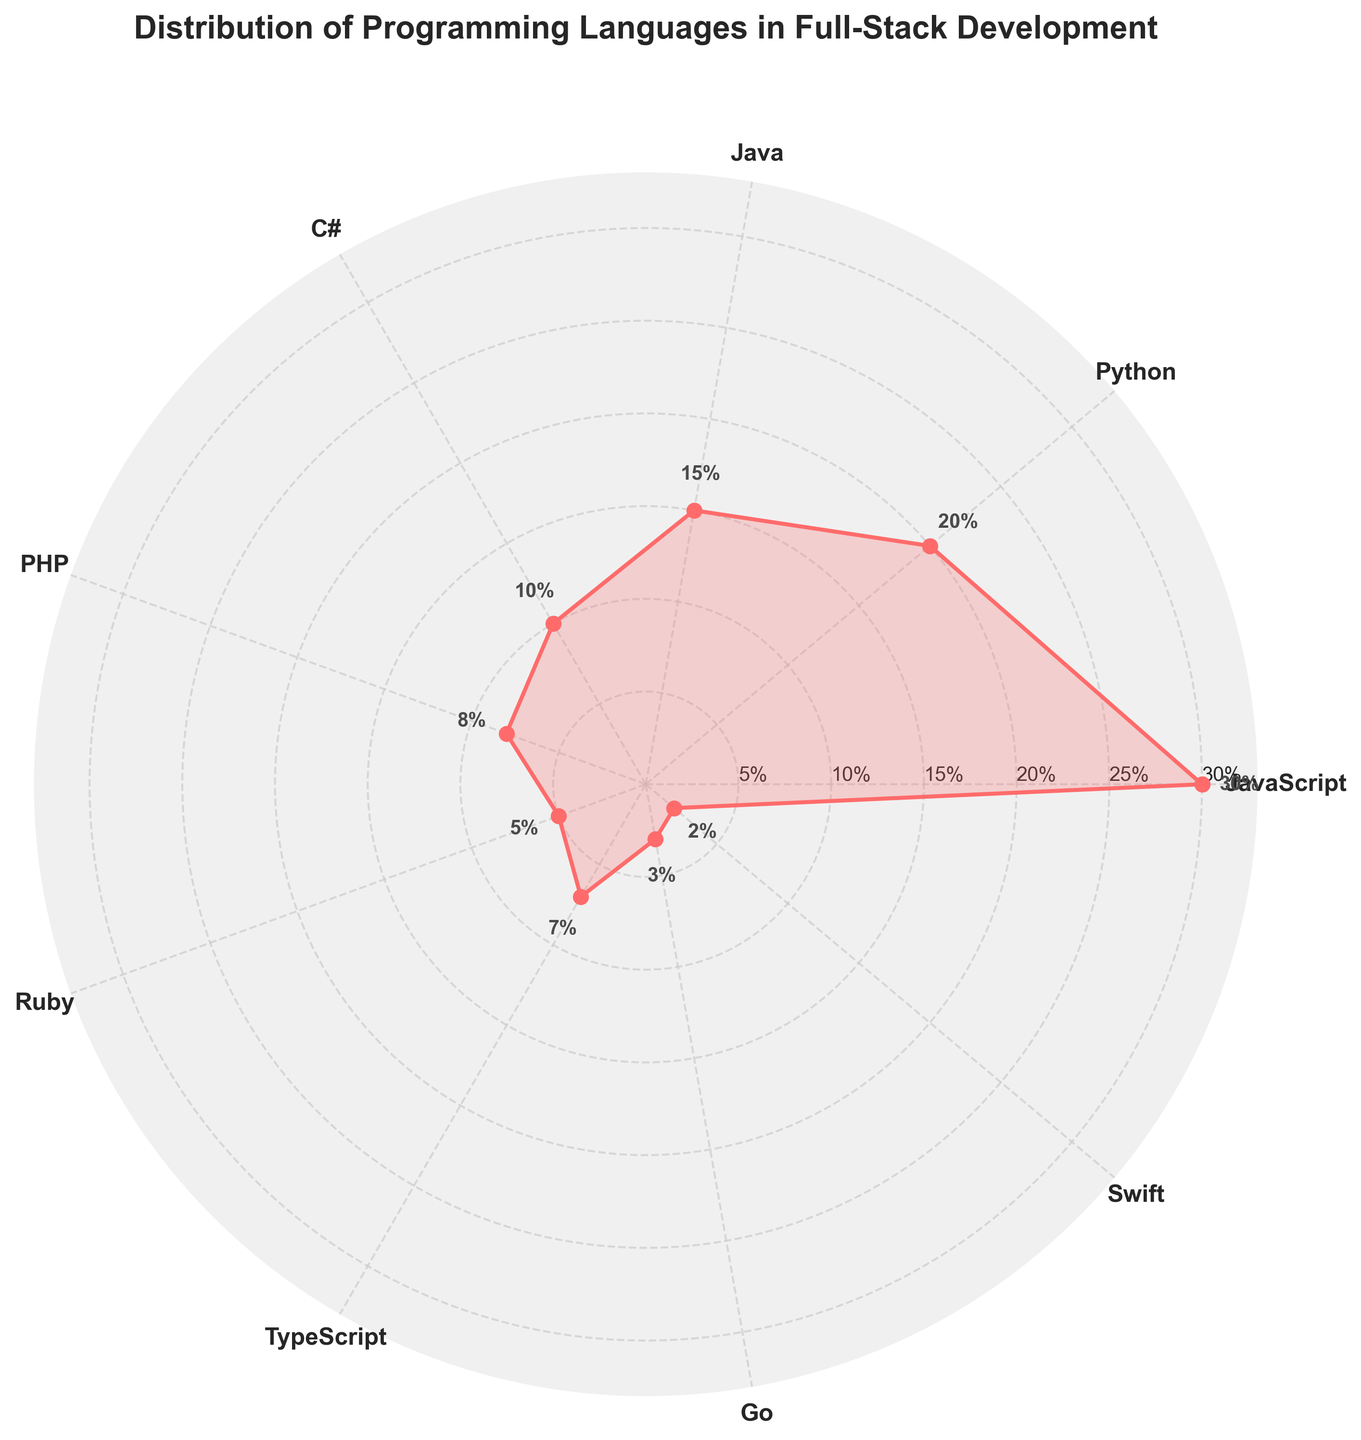Which programming language has the highest percentage in full-stack development? Looking at the polar chart, the largest segment goes up to 30%, which corresponds to the JavaScript label.
Answer: JavaScript How many programming languages have a percentage of use greater than 10%? By inspecting the polar chart, the languages with percentages greater than 10% are JavaScript (30%), Python (20%), and Java (15%). These are three languages.
Answer: 3 What is the combined percentage used for PHP, Ruby, TypeScript, Go, and Swift? Summing up the percentages for PHP (8%), Ruby (5%), TypeScript (7%), Go (3%), and Swift (2%) gives 8 + 5 + 7 + 3 + 2 = 25%.
Answer: 25% Which programming language has the smallest percentage in full-stack development? The smallest segment on the polar chart is marked at 2%, which corresponds to the Swift label.
Answer: Swift How does the usage of Python compare to the usage of C#? The chart shows Python at 20% and C# at 10%. Therefore, Python is used twice as much as C#.
Answer: Python is used twice as much as C# What is the average percentage of use among Java, PHP, and TypeScript? The percentages for Java, PHP, and TypeScript are 15%, 8%, and 7%, respectively. The average is calculated as (15 + 8 + 7) / 3 = 30 / 3 = 10%.
Answer: 10% What is the difference in usage percentage between JavaScript and the combined usage of PHP and Ruby? JavaScript is at 30%. The sum of PHP and Ruby is 8% + 5% = 13%. The difference is 30% - 13% = 17%.
Answer: 17% Are there any programming languages with a usage percentage double or more than that of Ruby? Ruby has a usage percentage of 5%. Languages with double or more are JavaScript (30%), Python (20%), Java (15%), and C# (10%), all of which are greater than 10%.
Answer: Yes What is the angular distance between JavaScript and Python and between Python and Java on the polar chart? The angular distance between JavaScript and Python and Python and Java is both one segment each in the polar chart, as they are adjacent to each other. Each segment is 360° / 9 = 40°. The distances are the same, which is 40°.
Answer: 40° Which programming language has a percentage closest to the average of the percentages for Python and C#? The average of Python (20%) and C# (10%) is (20 + 10) / 2 = 15%. The closest percentage to 15% is Java, which is exactly 15%.
Answer: Java 